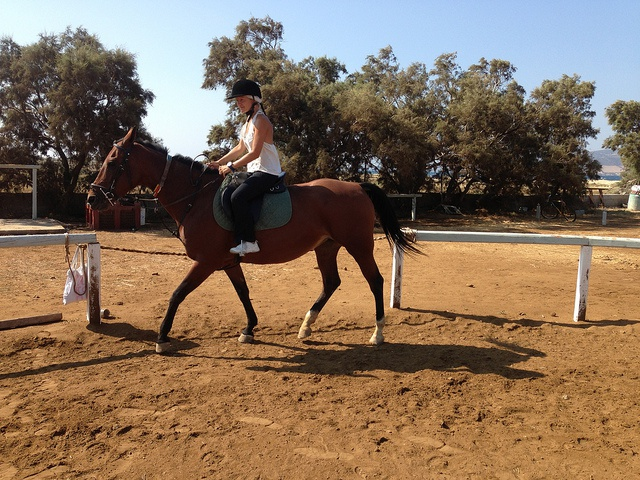Describe the objects in this image and their specific colors. I can see horse in white, black, tan, maroon, and gray tones, people in white, black, maroon, and gray tones, and bicycle in white, black, maroon, and gray tones in this image. 